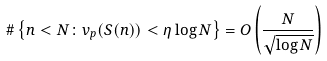<formula> <loc_0><loc_0><loc_500><loc_500>\# \left \{ n < N \colon v _ { p } ( S ( n ) ) < \eta \log N \right \} = O \left ( \frac { N } { \sqrt { \log N } } \right )</formula> 